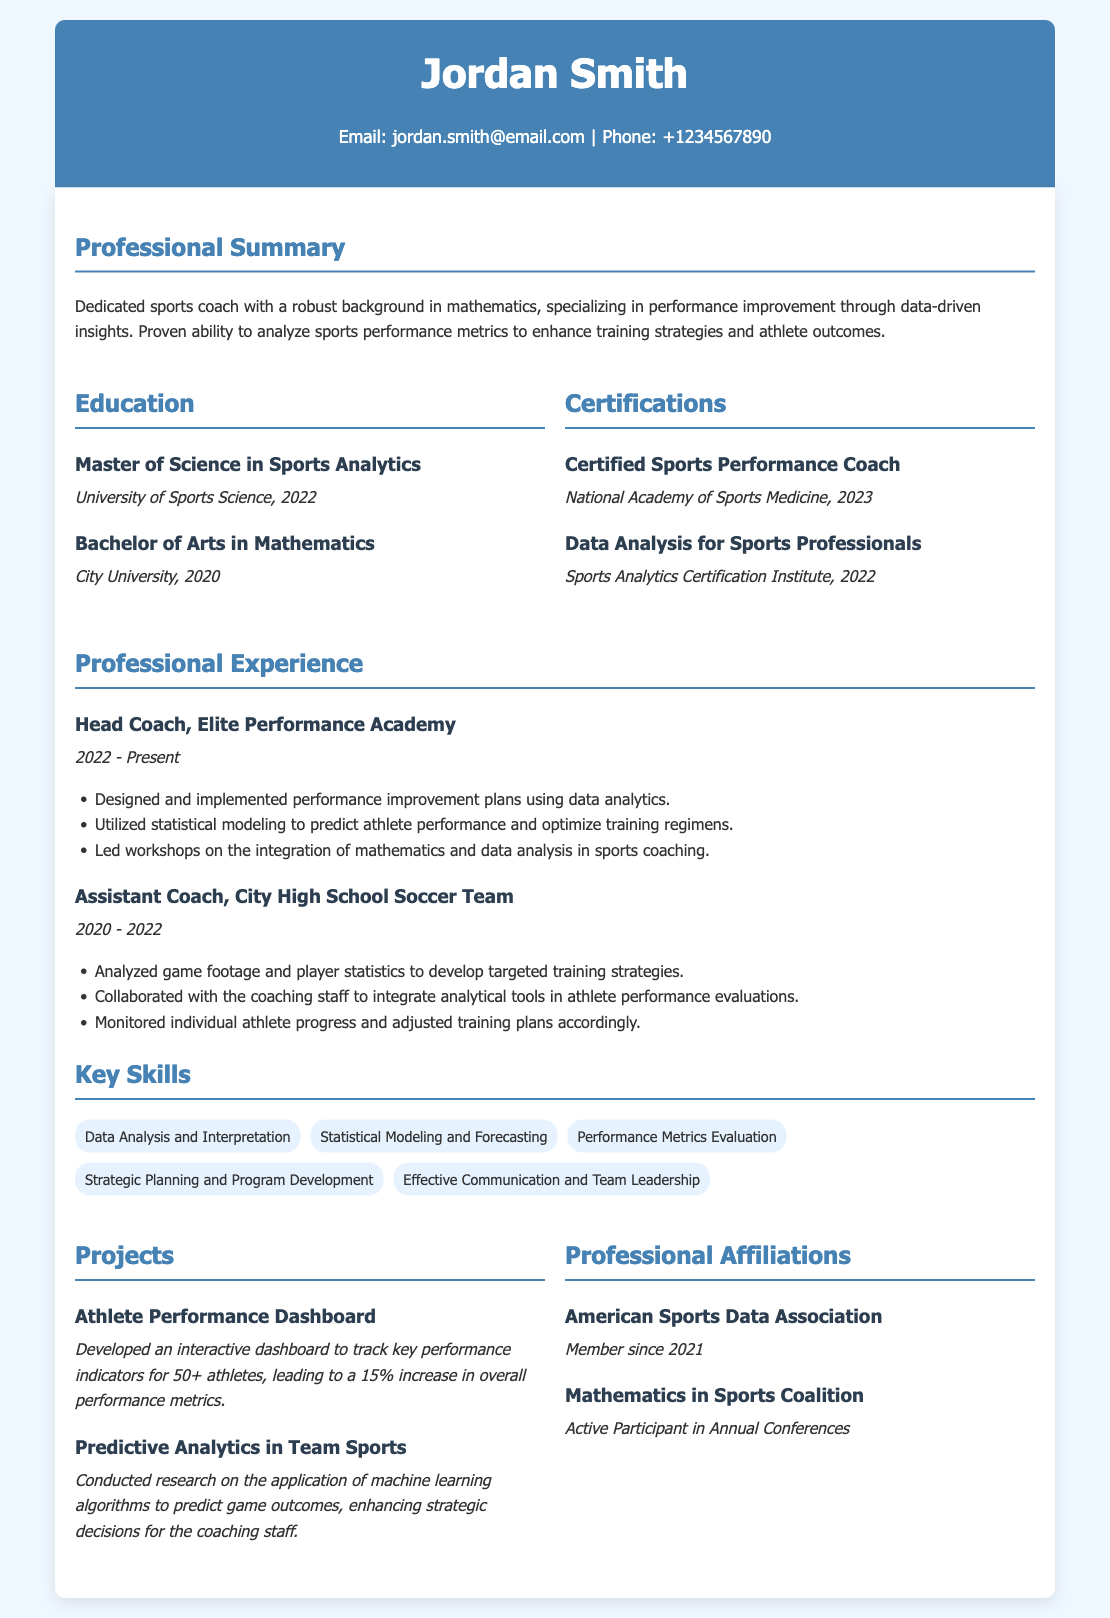What is the name of the person? The person's name is mentioned prominently at the top of the document.
Answer: Jordan Smith What is the latest certification obtained? The latest certification is listed under the certifications section, and it includes the most recent year.
Answer: Certified Sports Performance Coach In what year did Jordan Smith complete his Master of Science? The year is specified next to the degree in the education section.
Answer: 2022 How many years of experience does Jordan Smith have as a Head Coach? The time frame for the Head Coach position is provided in the experience section, allowing for easy calculation.
Answer: 1 year What percentage increase in performance metrics was achieved through the Athlete Performance Dashboard project? The percentage increase is noted in the description of the project in the projects section.
Answer: 15% What is the focus of the professional summary? The focus is encapsulated in key terms within the summary, particularly related to performance and mathematics.
Answer: Performance improvement through data-driven insights Which organization has Jordan Smith been a member of since 2021? The organization is explicitly mentioned in the professional affiliations section.
Answer: American Sports Data Association What degree did Jordan Smith obtain at City University? The degree is stated in the education section, clearly identifying the field of study.
Answer: Bachelor of Arts in Mathematics 